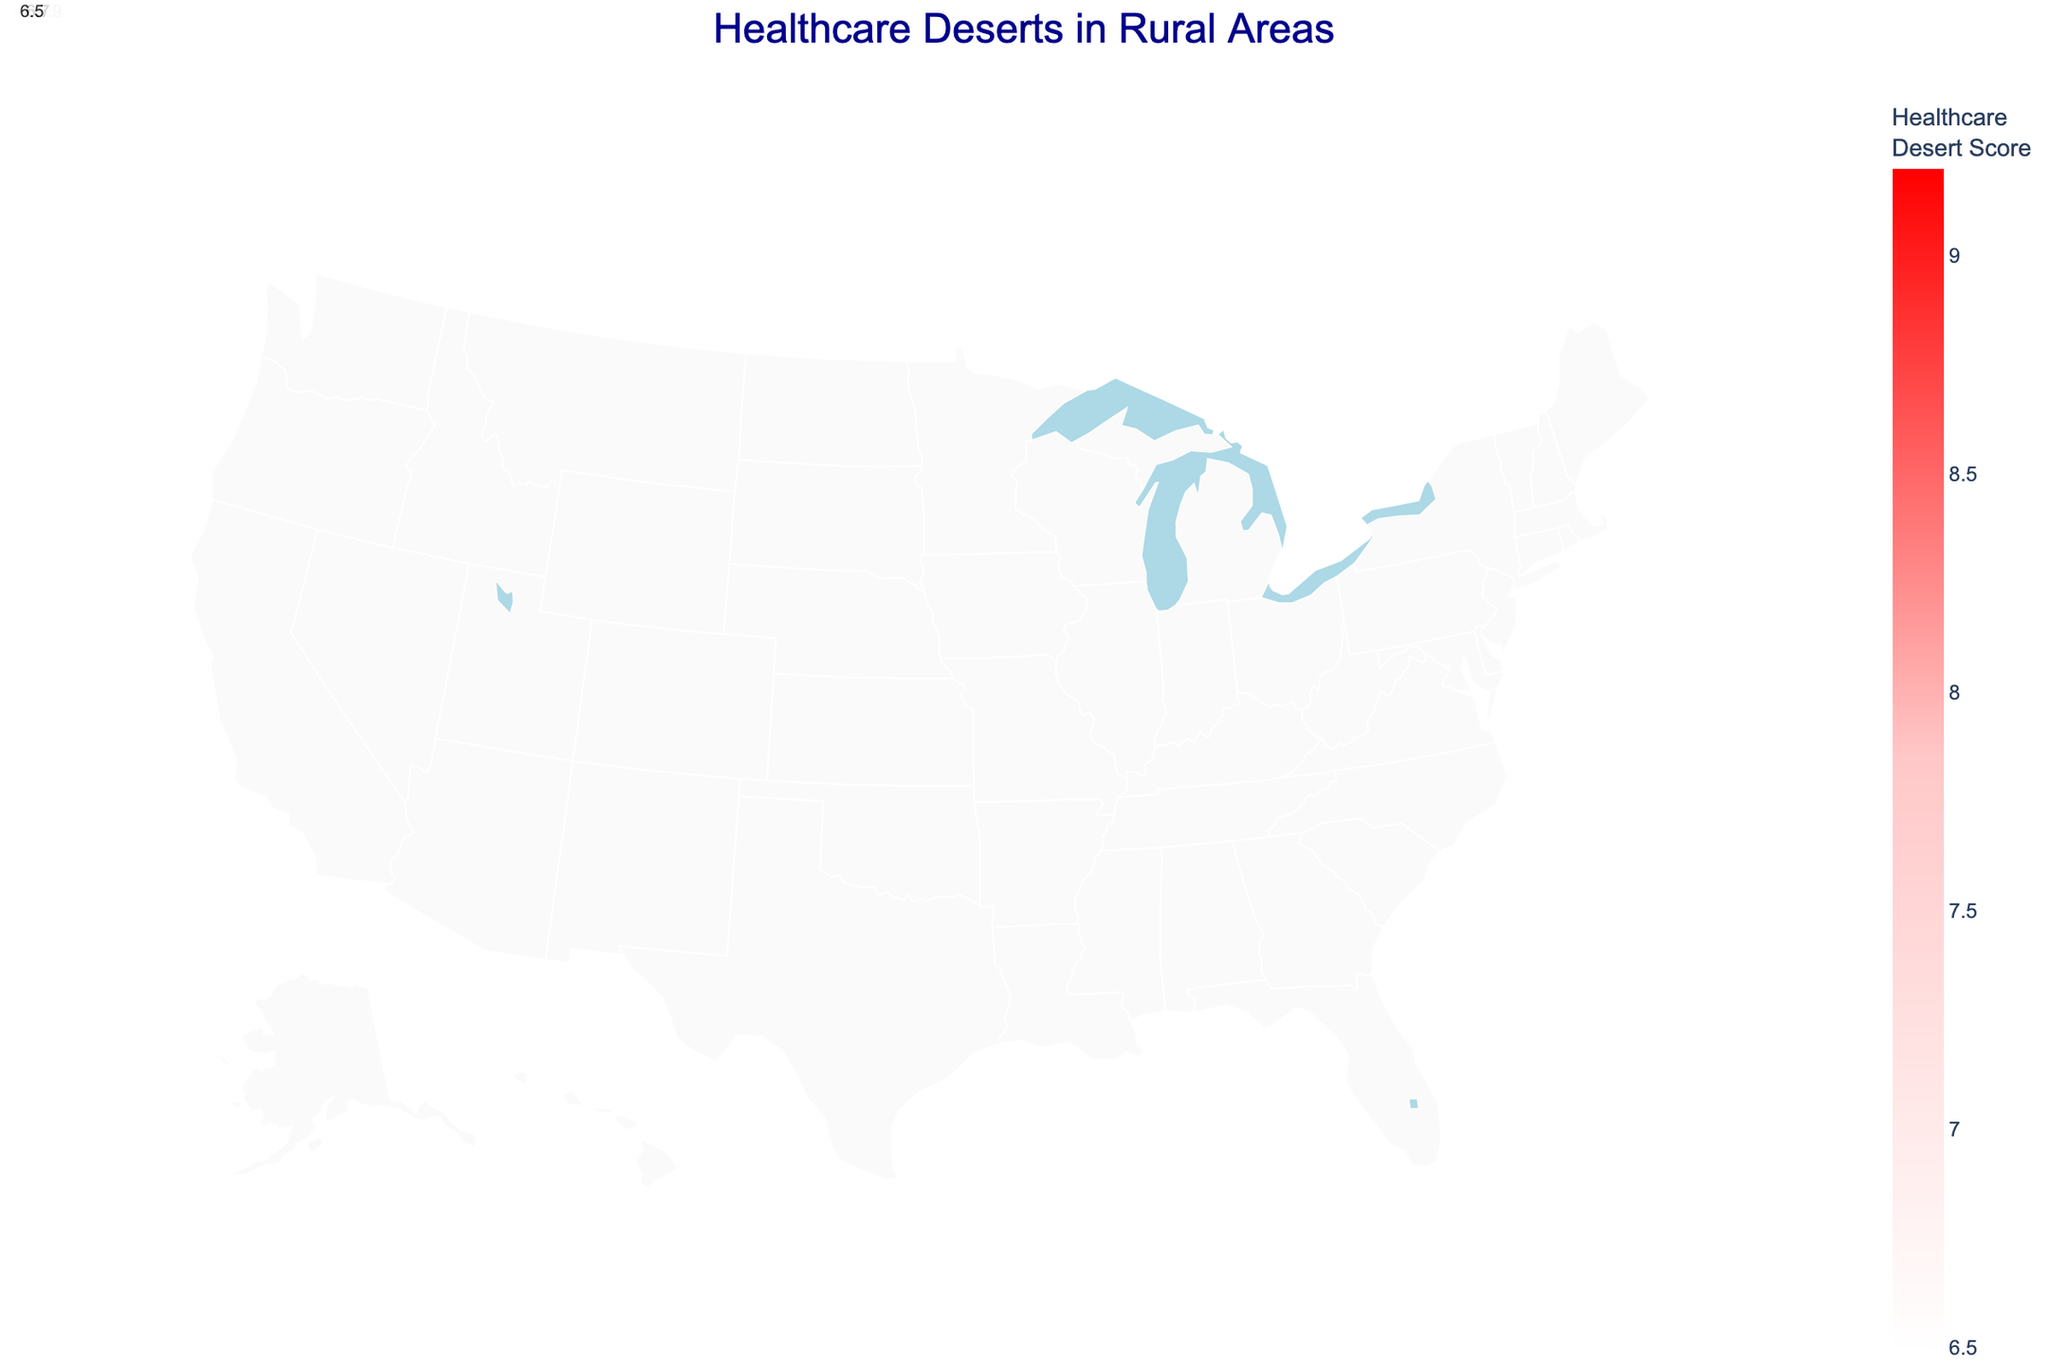What's the title of the figure? The title of the figure is usually prominently displayed at the top of the chart. In this case, it's indicated as "Healthcare Deserts in Rural Areas".
Answer: Healthcare Deserts in Rural Areas Which state has the highest Healthcare Desert Score? To determine the state with the highest Healthcare Desert Score, look for the data point with the highest value on the color gradient. The state with a score of 9.2 is Montana.
Answer: Montana How many states are displayed in the figure? Each unique data point represents a different state. By counting the different states listed, it's evident there are 14 states.
Answer: 14 How is the color coding determined in the figure? The color coding is based on the Healthcare Desert Score, with the scale moving from light colors for lower scores to darker red colors for higher scores.
Answer: By Healthcare Desert Score Which county has the longest distance to the nearest hospital? Hovering over each county reveals the "Nearest Hospital Distance (miles)" information. The county with the longest distance is Lake and Peninsula in Alaska, with 120 miles.
Answer: Lake and Peninsula What state has the highest number of Primary Care Physicians per 100k? Hover over each state to see the number of primary care physicians. Oregon (Wheeler County) has the highest with 45 primary care physicians per 100k.
Answer: Oregon Compare the Healthcare Desert Scores of Texas and Nebraska. Which one is higher? By comparing the Healthcare Desert Scores, Texas (Loving County) has a score of 8.9, and Nebraska (Arthur County) has a score of 8.7. Hence, Texas has the higher score.
Answer: Texas Which county in Oklahoma is represented in the figure, and what is its Healthcare Desert Score? From the data provided, the county in Oklahoma represented on the map is Cimarron, and its Healthcare Desert Score is 7.1.
Answer: Cimarron, 7.1 What is the average Nearest Hospital Distance for the states listed? Adding up the distances (78 + 82 + 65 + 70 + 55 + 95 + 120 + 45 + 60 + 72 + 68 + 58 + 52 + 48) and dividing by the number of states (14) gives 918 / 14 = 65.57 miles.
Answer: 65.57 miles 